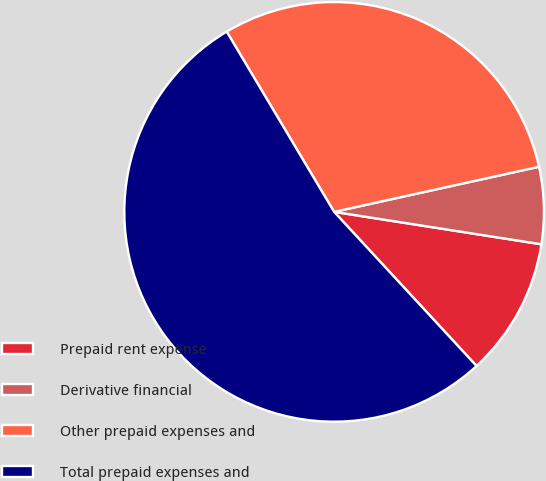<chart> <loc_0><loc_0><loc_500><loc_500><pie_chart><fcel>Prepaid rent expense<fcel>Derivative financial<fcel>Other prepaid expenses and<fcel>Total prepaid expenses and<nl><fcel>10.66%<fcel>5.92%<fcel>30.11%<fcel>53.32%<nl></chart> 